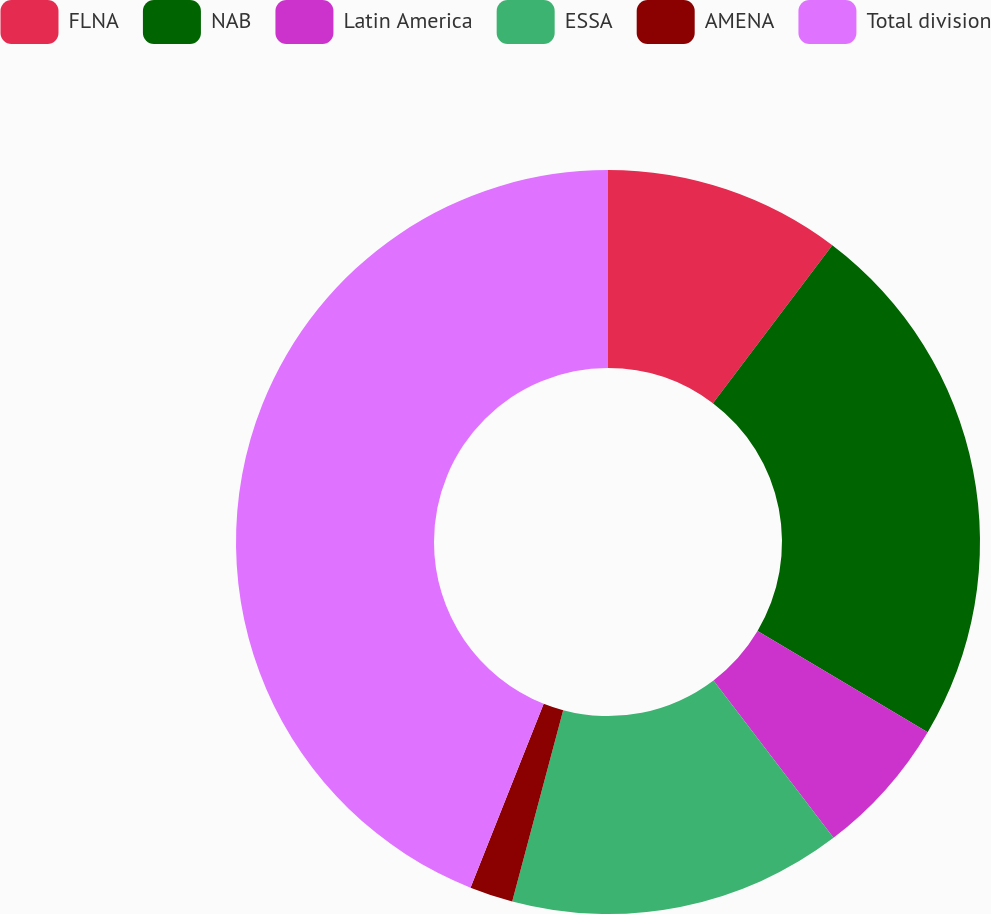Convert chart to OTSL. <chart><loc_0><loc_0><loc_500><loc_500><pie_chart><fcel>FLNA<fcel>NAB<fcel>Latin America<fcel>ESSA<fcel>AMENA<fcel>Total division<nl><fcel>10.3%<fcel>23.24%<fcel>6.09%<fcel>14.51%<fcel>1.88%<fcel>43.97%<nl></chart> 